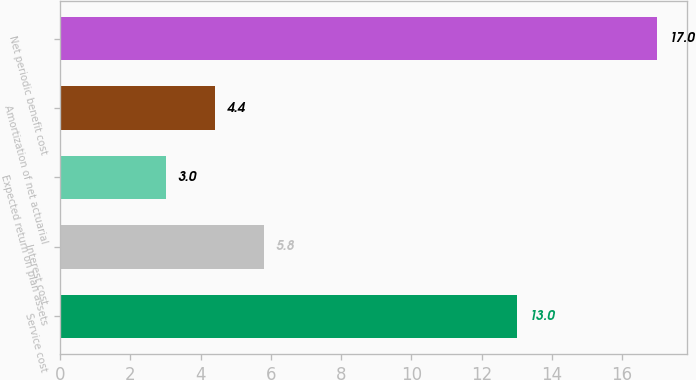Convert chart to OTSL. <chart><loc_0><loc_0><loc_500><loc_500><bar_chart><fcel>Service cost<fcel>Interest cost<fcel>Expected return on plan assets<fcel>Amortization of net actuarial<fcel>Net periodic benefit cost<nl><fcel>13<fcel>5.8<fcel>3<fcel>4.4<fcel>17<nl></chart> 